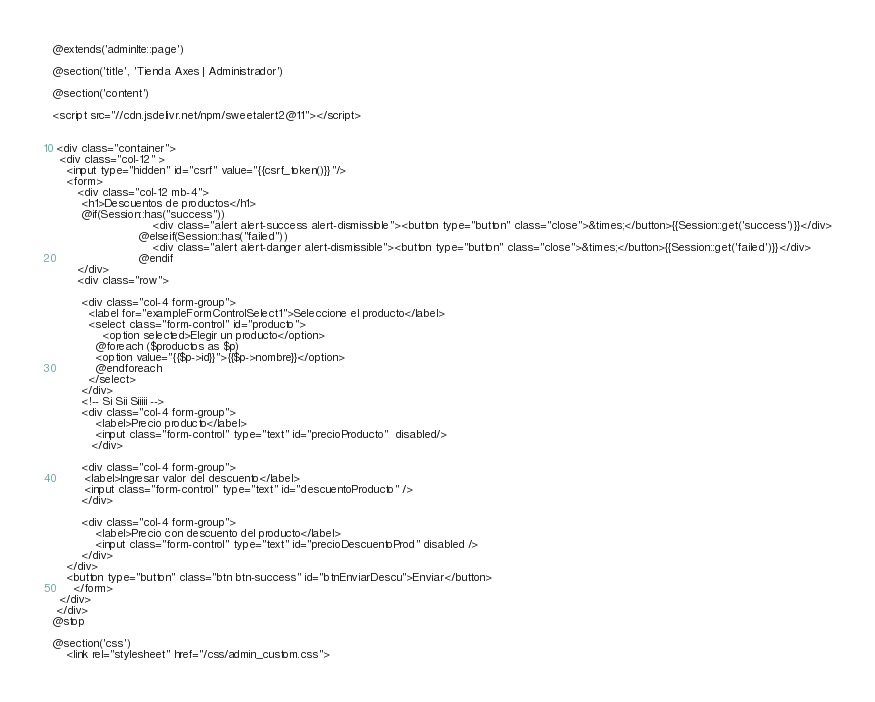<code> <loc_0><loc_0><loc_500><loc_500><_PHP_>@extends('adminlte::page')

@section('title', 'Tienda Axes | Administrador')

@section('content')

<script src="//cdn.jsdelivr.net/npm/sweetalert2@11"></script>


 <div class="container">
  <div class="col-12" >
    <input type="hidden" id="csrf" value="{{csrf_token()}}"/>
    <form>
       <div class="col-12 mb-4">
        <h1>Descuentos de productos</h1>
        @if(Session::has("success"))
                            <div class="alert alert-success alert-dismissible"><button type="button" class="close">&times;</button>{{Session::get('success')}}</div>
                        @elseif(Session::has("failed"))
                            <div class="alert alert-danger alert-dismissible"><button type="button" class="close">&times;</button>{{Session::get('failed')}}</div>
                        @endif
       </div>
       <div class="row">
 
        <div class="col-4 form-group">
          <label for="exampleFormControlSelect1">Seleccione el producto</label>
          <select class="form-control" id="producto">
              <option selected>Elegir un producto</option>
            @foreach ($productos as $p)
            <option value="{{$p->id}}">{{$p->nombre}}</option>      
            @endforeach    
          </select>
        </div>
        <!-- Si Sii Siiiii -->
        <div class="col-4 form-group">
            <label>Precio producto</label>
            <input class="form-control" type="text" id="precioProducto"  disabled/>
           </div>
        
        <div class="col-4 form-group">
         <label>Ingresar valor del descuento</label>
         <input class="form-control" type="text" id="descuentoProducto" />
        </div>
        
        <div class="col-4 form-group">
            <label>Precio con descuento del producto</label>
            <input class="form-control" type="text" id="precioDescuentoProd" disabled />
        </div>
    </div>
    <button type="button" class="btn btn-success" id="btnEnviarDescu">Enviar</button>
      </form>
  </div>
 </div>
@stop

@section('css')
    <link rel="stylesheet" href="/css/admin_custom.css"></code> 